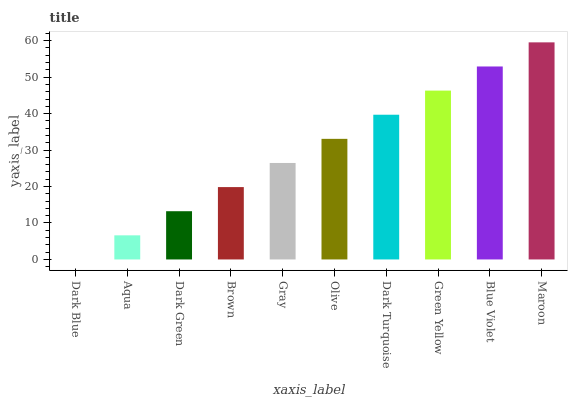Is Dark Blue the minimum?
Answer yes or no. Yes. Is Maroon the maximum?
Answer yes or no. Yes. Is Aqua the minimum?
Answer yes or no. No. Is Aqua the maximum?
Answer yes or no. No. Is Aqua greater than Dark Blue?
Answer yes or no. Yes. Is Dark Blue less than Aqua?
Answer yes or no. Yes. Is Dark Blue greater than Aqua?
Answer yes or no. No. Is Aqua less than Dark Blue?
Answer yes or no. No. Is Olive the high median?
Answer yes or no. Yes. Is Gray the low median?
Answer yes or no. Yes. Is Dark Turquoise the high median?
Answer yes or no. No. Is Aqua the low median?
Answer yes or no. No. 